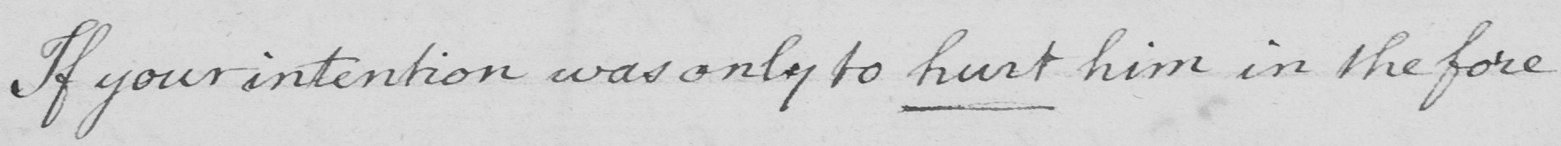Transcribe the text shown in this historical manuscript line. If your intention was only to hurt him in the fore- 